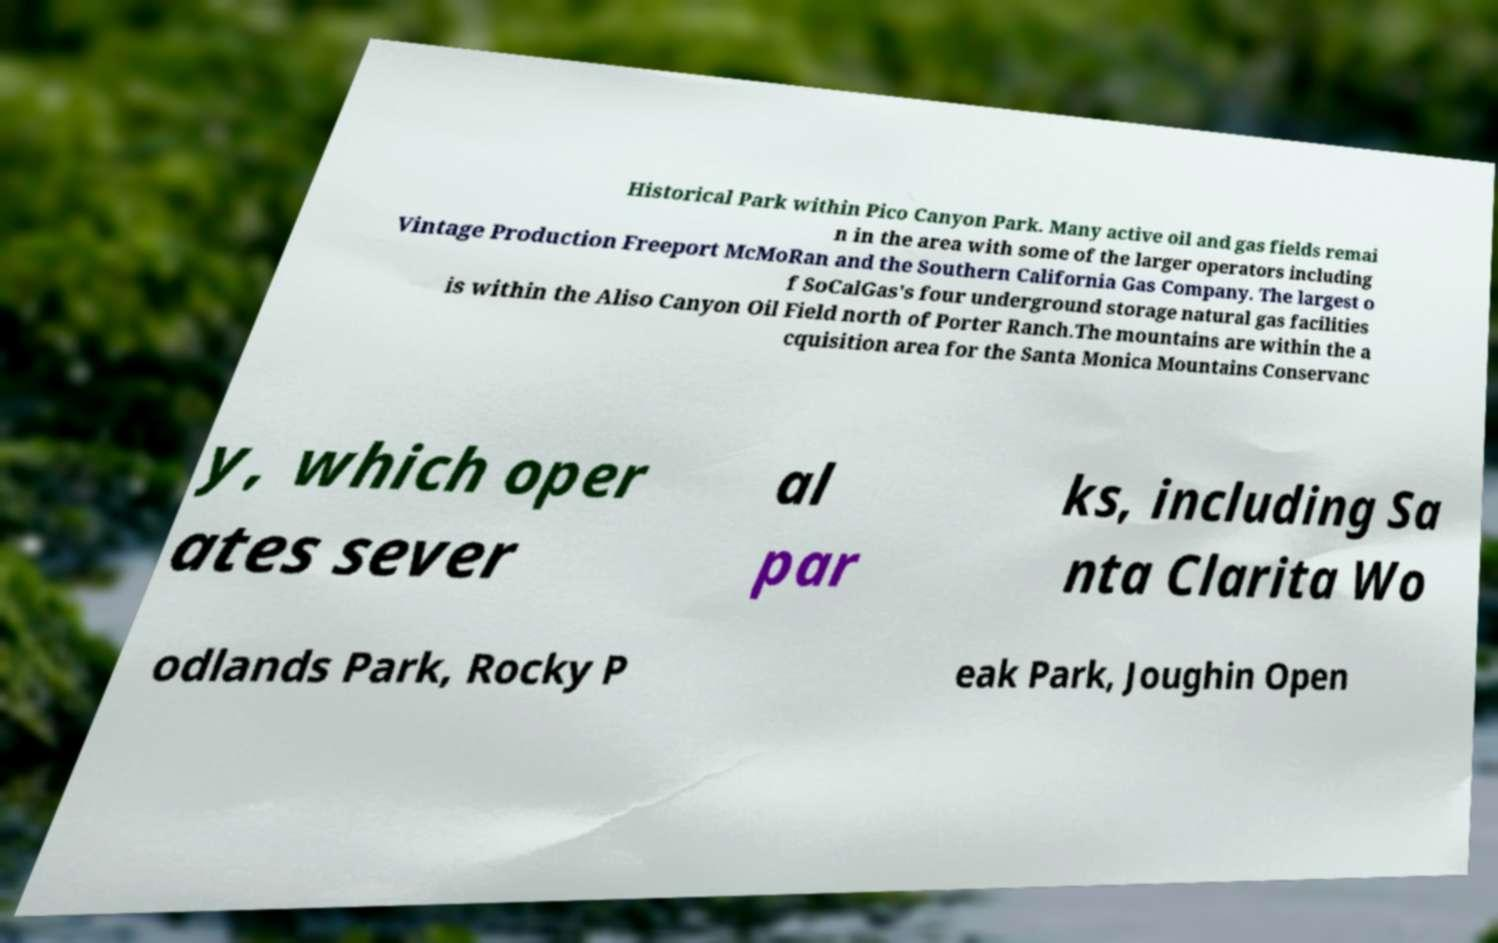Please read and relay the text visible in this image. What does it say? Historical Park within Pico Canyon Park. Many active oil and gas fields remai n in the area with some of the larger operators including Vintage Production Freeport McMoRan and the Southern California Gas Company. The largest o f SoCalGas's four underground storage natural gas facilities is within the Aliso Canyon Oil Field north of Porter Ranch.The mountains are within the a cquisition area for the Santa Monica Mountains Conservanc y, which oper ates sever al par ks, including Sa nta Clarita Wo odlands Park, Rocky P eak Park, Joughin Open 